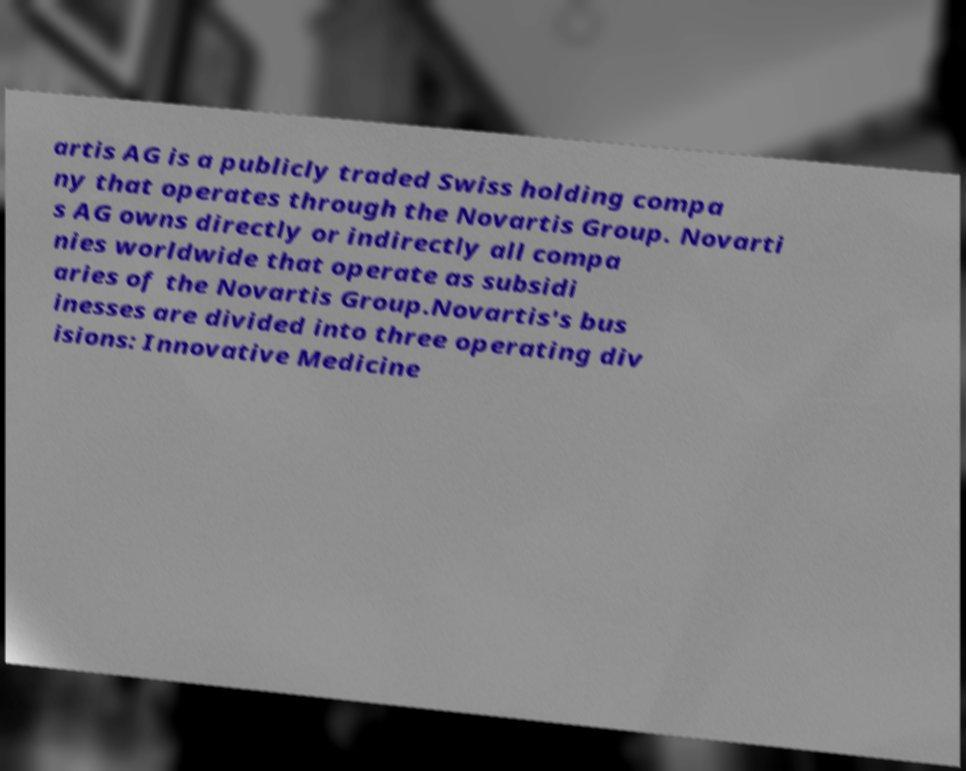I need the written content from this picture converted into text. Can you do that? artis AG is a publicly traded Swiss holding compa ny that operates through the Novartis Group. Novarti s AG owns directly or indirectly all compa nies worldwide that operate as subsidi aries of the Novartis Group.Novartis's bus inesses are divided into three operating div isions: Innovative Medicine 